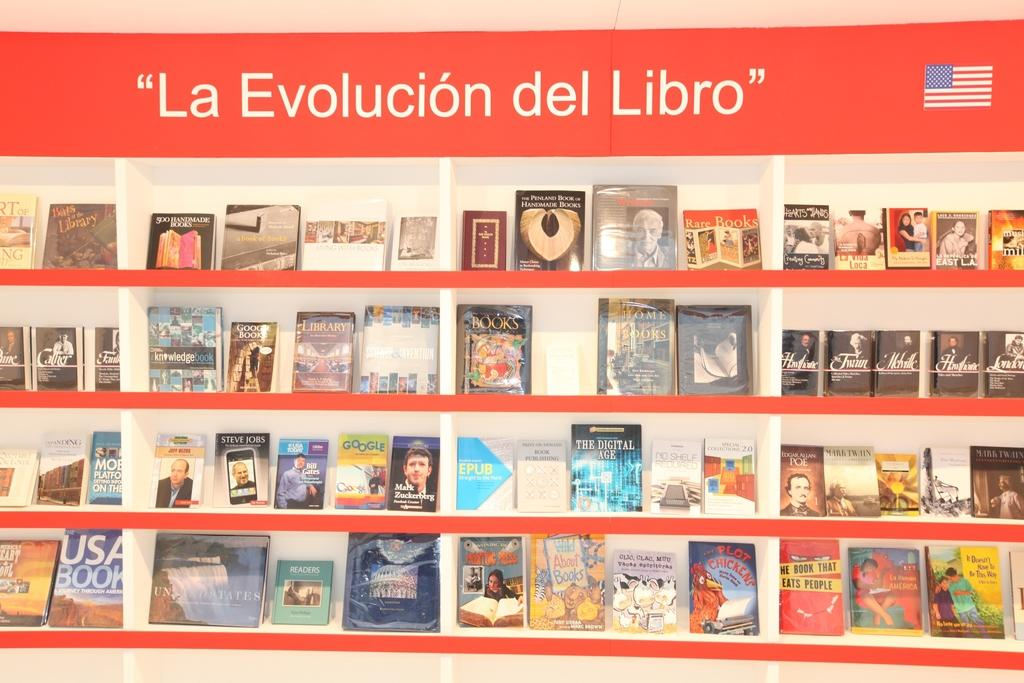What is the main subject of the image? The main subject of the image is a group of books. How are the books arranged in the image? The books are placed in an order on shelves. What can be seen at the top of the image? There is text visible at the top of the image, as well as a picture of a flag. What type of horn is being played by the quill in the image? There is no horn or quill present in the image; it features a group of books arranged on shelves with text and a picture of a flag at the top. 